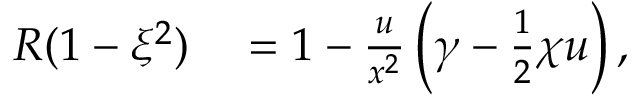<formula> <loc_0><loc_0><loc_500><loc_500>\begin{array} { r l } { R ( 1 - \xi ^ { 2 } ) } & = 1 - \frac { u } { x ^ { 2 } } \left ( \gamma - \frac { 1 } { 2 } \chi u \right ) , } \end{array}</formula> 